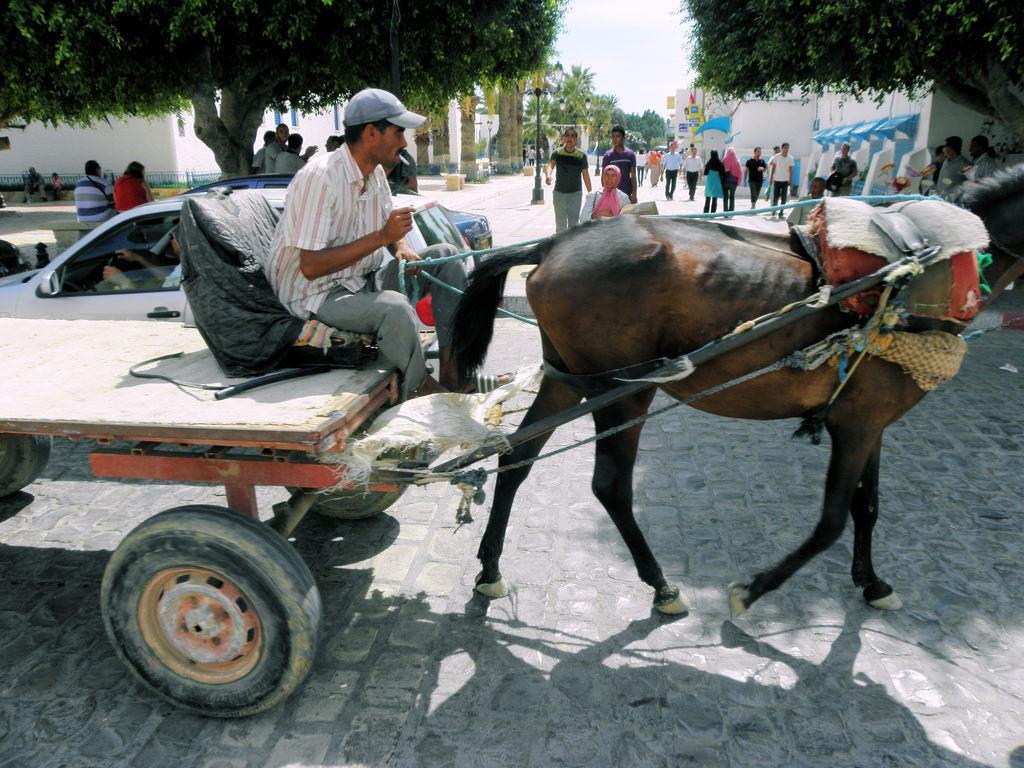Can you describe this image briefly? In the picture I can see a person sitting on the cart is riding the horse on the road. Here I can see a few more cars moving on the road, I can see people walking on the road, I can see a few people sitting on the benches, I can see light poles, trees, buildings and the sky in the background. 